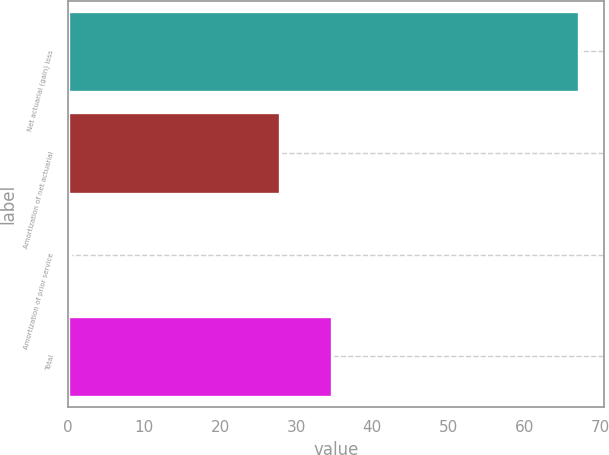<chart> <loc_0><loc_0><loc_500><loc_500><bar_chart><fcel>Net actuarial (gain) loss<fcel>Amortization of net actuarial<fcel>Amortization of prior service<fcel>Total<nl><fcel>67.2<fcel>27.9<fcel>0.2<fcel>34.7<nl></chart> 